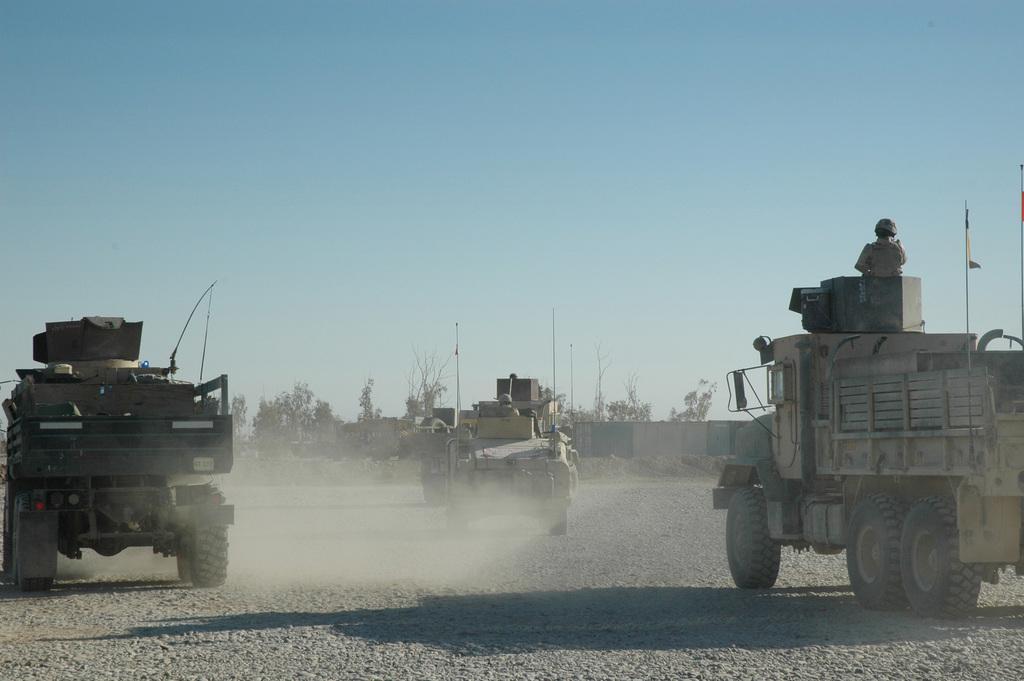Can you describe this image briefly? In this image there is one truck at left side of this image and there are two trucks in middle of this image and there is one truck at right side of this image and there is one person standing on the truck at right side of this image and there is a wall at right side of this image and there are some trees in the background and there is a sky at top of this image. 